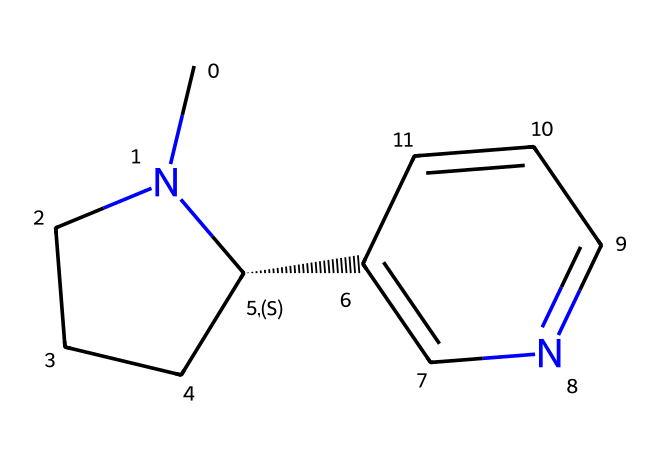What is the total number of carbon atoms in this structure? By examining the SMILES representation, we can count the number of carbon (C) atoms present. The representation includes several instances of 'C' with various connections indicating multiple carbon atoms are part of rings and chains in the structure. A total count will reveal there are 10 carbon atoms in this molecule.
Answer: 10 How many nitrogen atoms are present in the compound? The SMILES representation shows 'N' symbolizing nitrogen atoms. We can identify two distinct occurrences of 'N' in the structure, which indicates that there are two nitrogen atoms present in this chemical makeup.
Answer: 2 Is this compound aromatic in nature? To assess aromaticity, we can look for cyclic structures and delocalized pi electrons. This compound has a ring structure with nitrogen atoms and exhibits properties consistent with aromatic compounds, indicating it is indeed aromatic due to resonance stabilization.
Answer: yes What is the functional group present in this structure? The presence of nitrogen atoms within a cyclic structure suggests that this compound may have a functional group characteristic of alkaloids, which typically include amines or similar structures. Based on the structure, it can be identified as a pyridine functional group due to its nitrogen presence in a ring.
Answer: pyridine What class of compounds does this chemical belong to? Analyzing the features of this structure, including the presence of nitrogen and its cyclic nature, we recognize that it is categorized as an alkaloid, which are compounds primarily derived from plant sources that often exhibit pronounced physiological effects on humans.
Answer: alkaloid What is the stereochemistry at the chiral center? The '@' symbol in the SMILES denotes that there is a chiral center present in the structure. Evaluating the configuration of the surrounding groups from the chiral center indicates that the stereochemistry is S (senantiomer).
Answer: S 